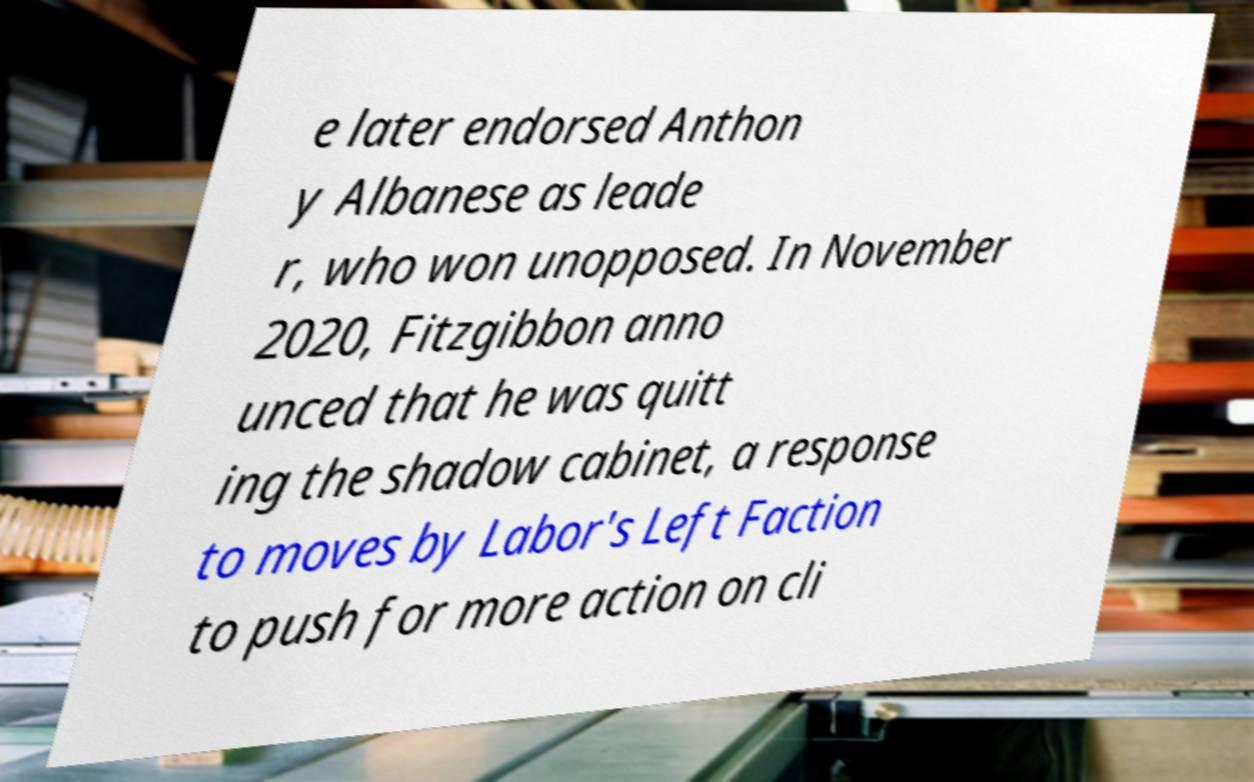There's text embedded in this image that I need extracted. Can you transcribe it verbatim? e later endorsed Anthon y Albanese as leade r, who won unopposed. In November 2020, Fitzgibbon anno unced that he was quitt ing the shadow cabinet, a response to moves by Labor's Left Faction to push for more action on cli 